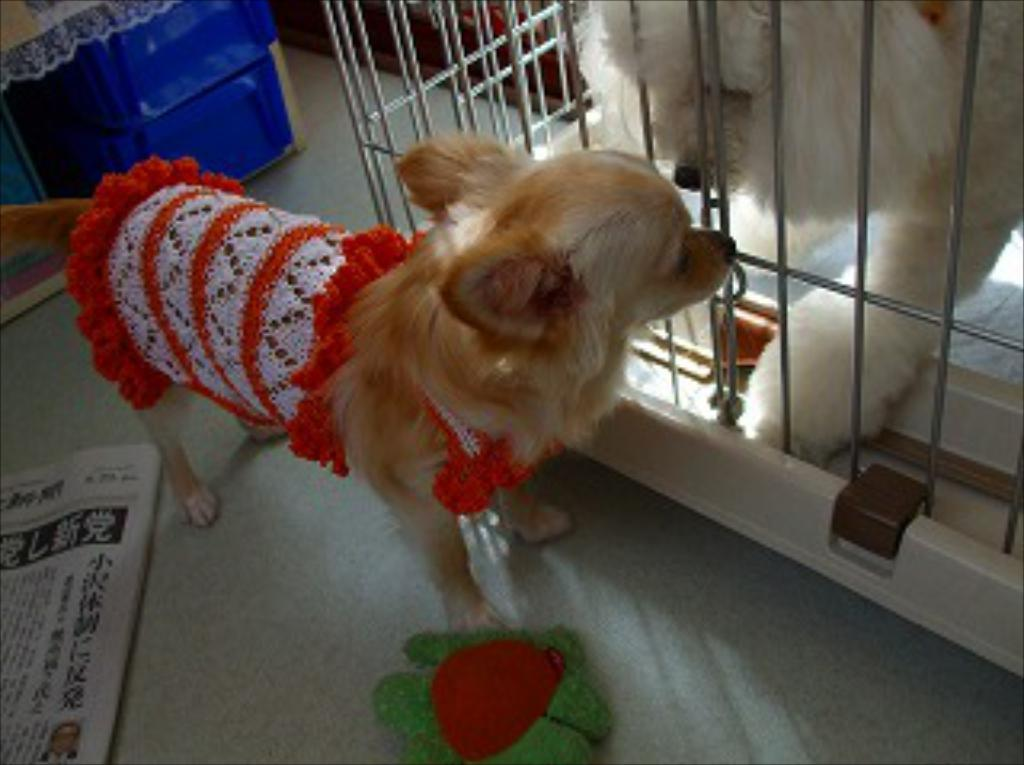What is located on the right side of the image? There is a cage on the right side of the image. What can be seen inside the cage? There is a dog inside the cage. What is the situation with the other dog in the image? There is another dog outside the cage. What is on the left side of the image? There is a box on the left side of the image. What is on the floor in the image? There is a newspaper on the floor. How many snakes are slithering around the box in the image? There are no snakes present in the image. What time is indicated on the clock in the image? There is no clock present in the image. 